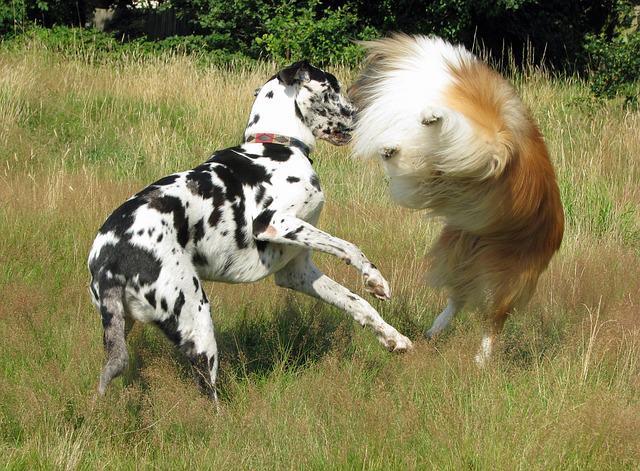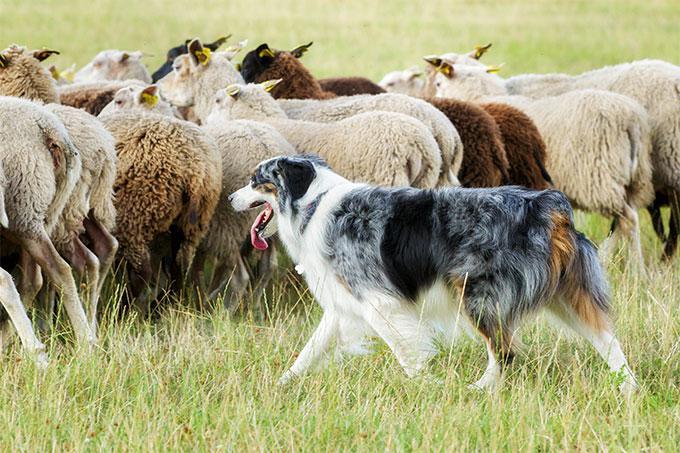The first image is the image on the left, the second image is the image on the right. Given the left and right images, does the statement "There are two dogs" hold true? Answer yes or no. No. The first image is the image on the left, the second image is the image on the right. Analyze the images presented: Is the assertion "In one image, a dog is shown with sheep." valid? Answer yes or no. Yes. 